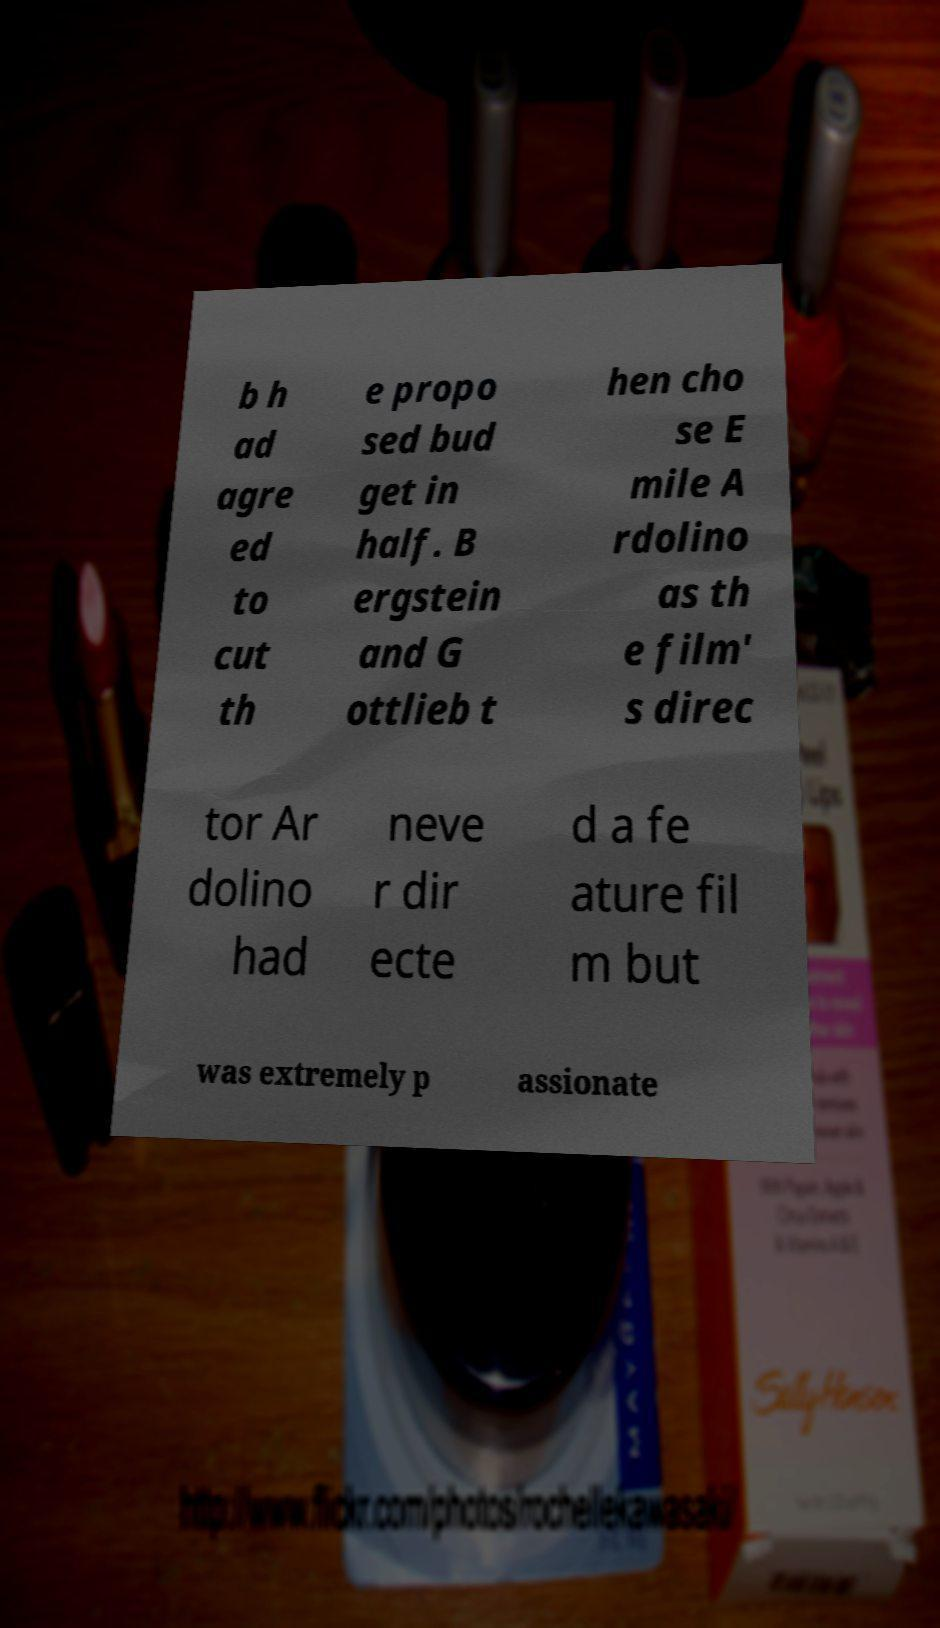Can you accurately transcribe the text from the provided image for me? b h ad agre ed to cut th e propo sed bud get in half. B ergstein and G ottlieb t hen cho se E mile A rdolino as th e film' s direc tor Ar dolino had neve r dir ecte d a fe ature fil m but was extremely p assionate 